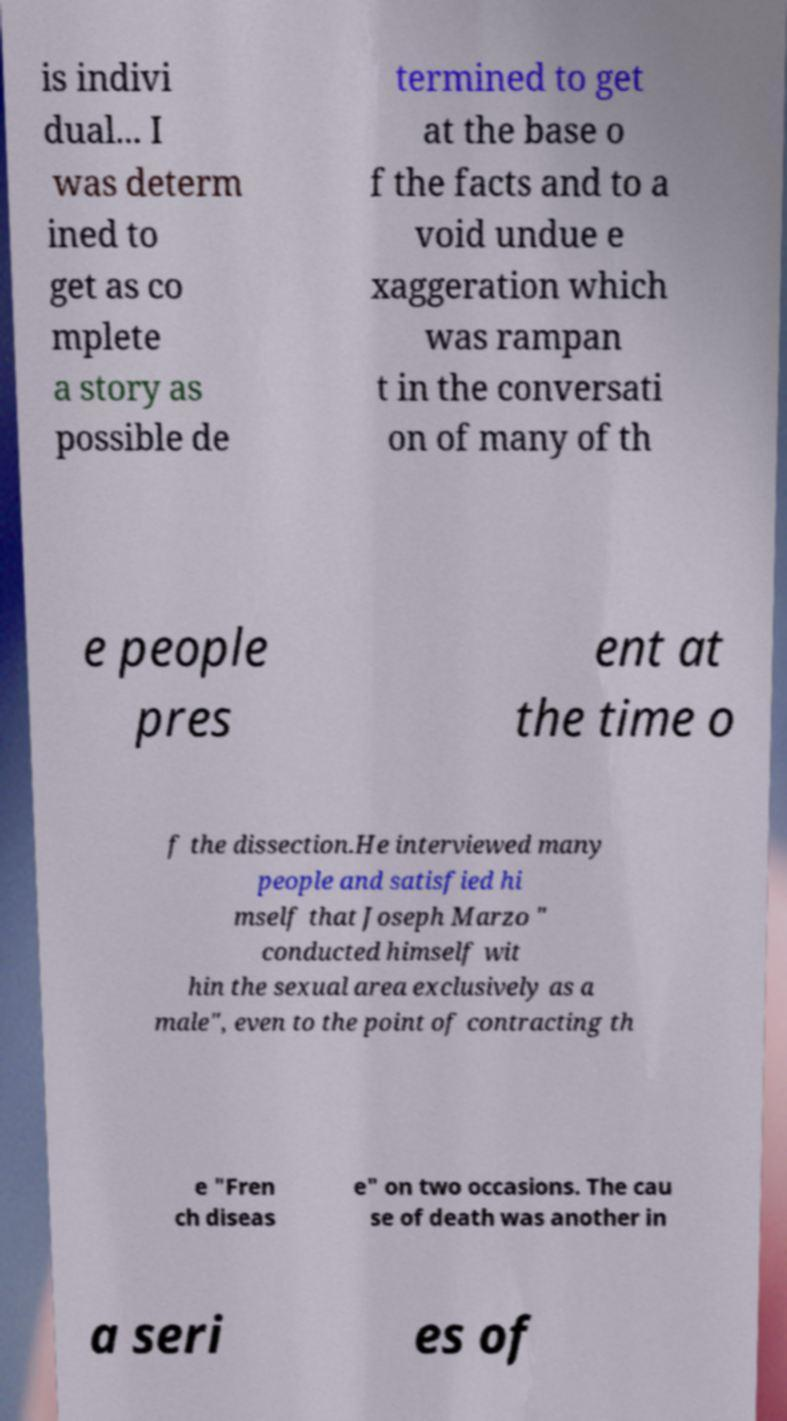Can you read and provide the text displayed in the image?This photo seems to have some interesting text. Can you extract and type it out for me? is indivi dual... I was determ ined to get as co mplete a story as possible de termined to get at the base o f the facts and to a void undue e xaggeration which was rampan t in the conversati on of many of th e people pres ent at the time o f the dissection.He interviewed many people and satisfied hi mself that Joseph Marzo " conducted himself wit hin the sexual area exclusively as a male", even to the point of contracting th e "Fren ch diseas e" on two occasions. The cau se of death was another in a seri es of 